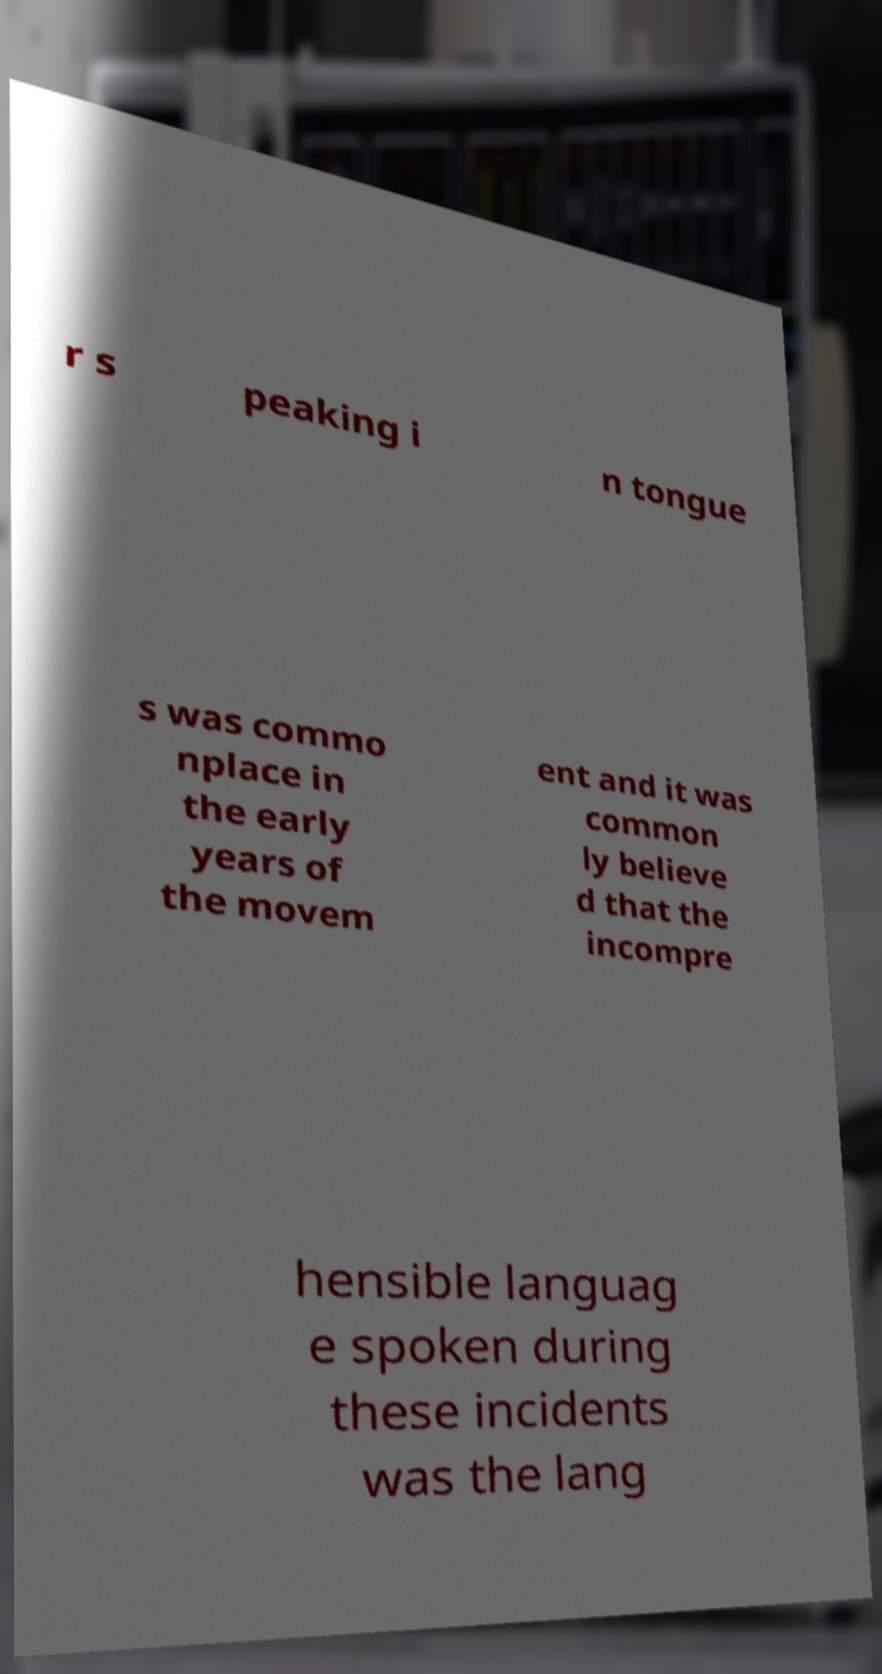For documentation purposes, I need the text within this image transcribed. Could you provide that? r s peaking i n tongue s was commo nplace in the early years of the movem ent and it was common ly believe d that the incompre hensible languag e spoken during these incidents was the lang 